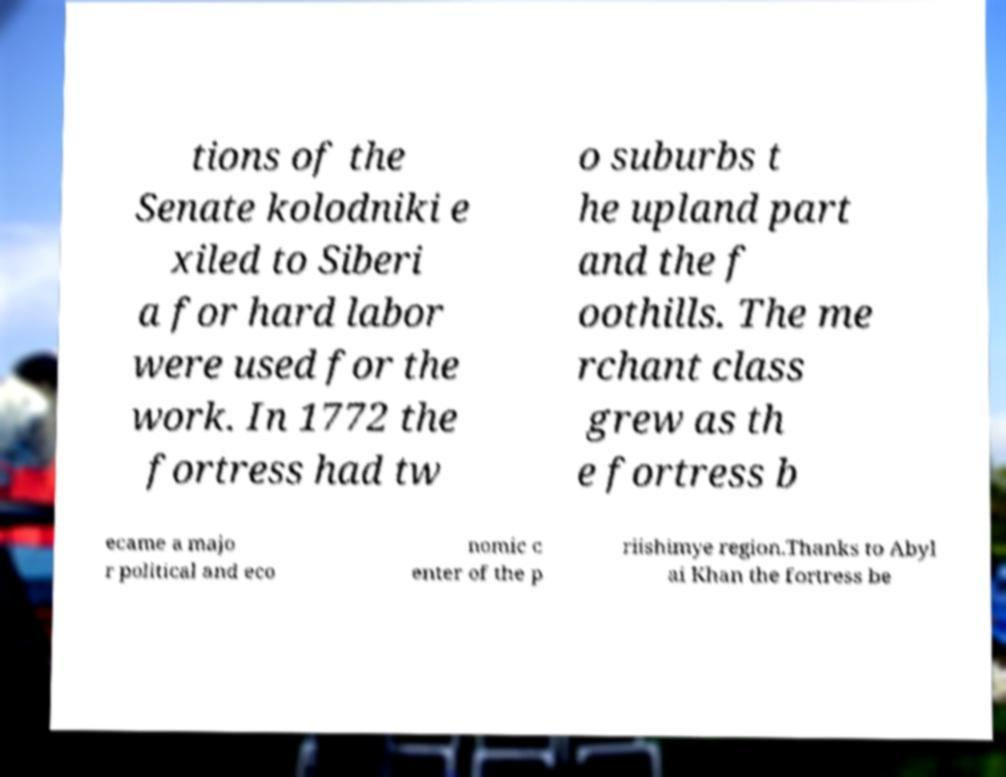I need the written content from this picture converted into text. Can you do that? tions of the Senate kolodniki e xiled to Siberi a for hard labor were used for the work. In 1772 the fortress had tw o suburbs t he upland part and the f oothills. The me rchant class grew as th e fortress b ecame a majo r political and eco nomic c enter of the p riishimye region.Thanks to Abyl ai Khan the fortress be 